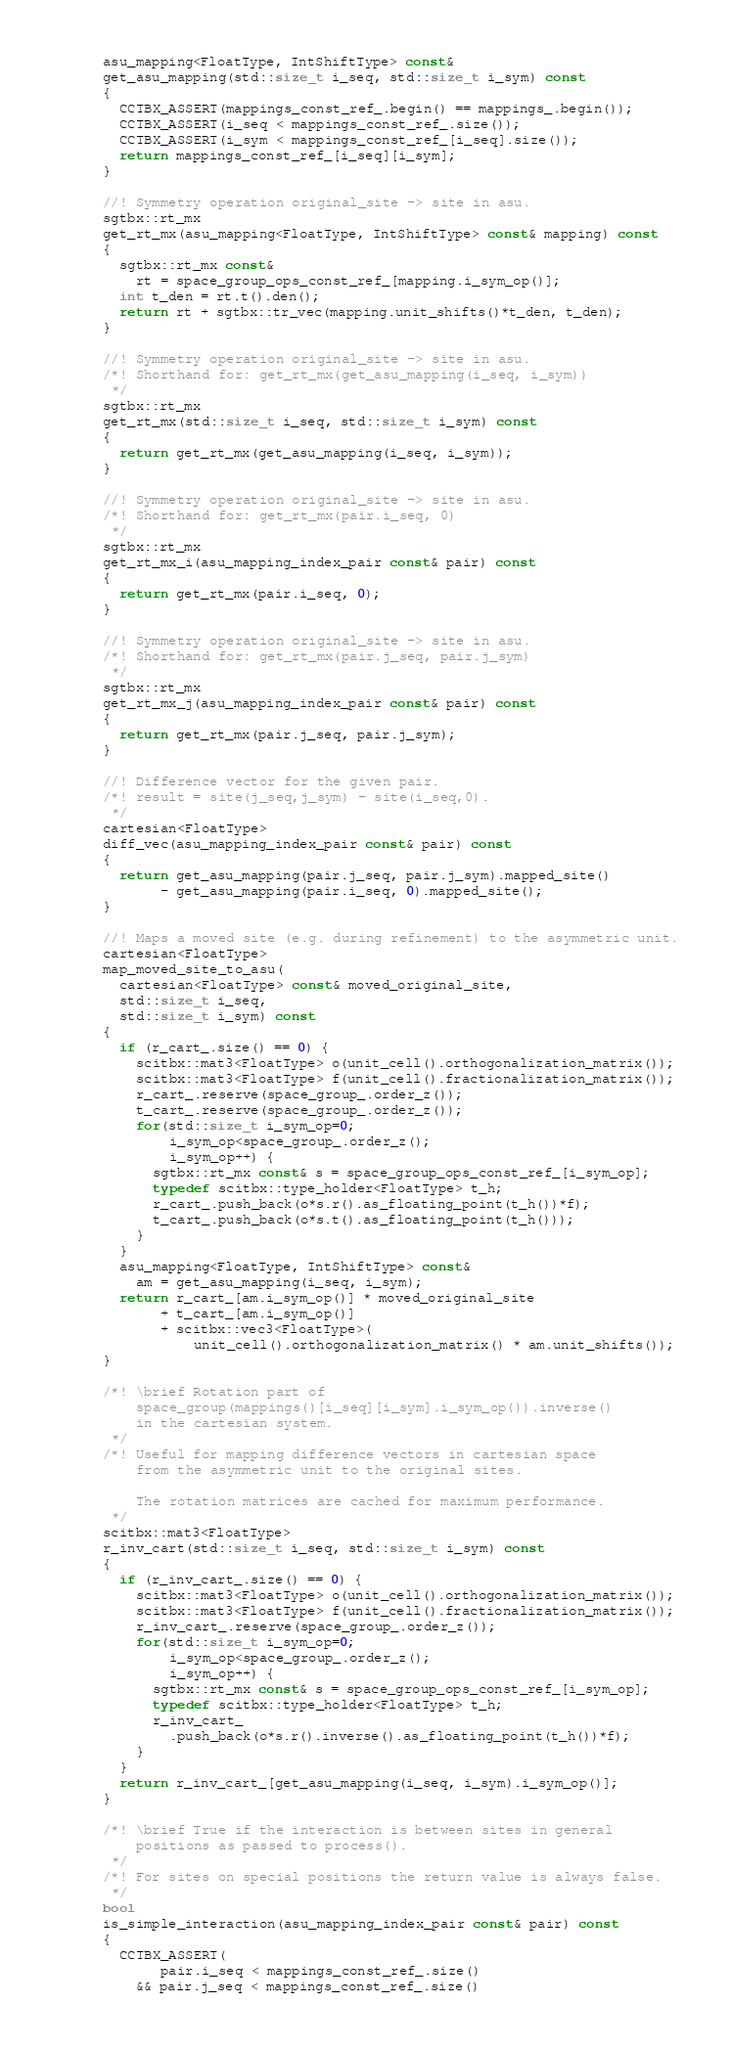Convert code to text. <code><loc_0><loc_0><loc_500><loc_500><_C_>      asu_mapping<FloatType, IntShiftType> const&
      get_asu_mapping(std::size_t i_seq, std::size_t i_sym) const
      {
        CCTBX_ASSERT(mappings_const_ref_.begin() == mappings_.begin());
        CCTBX_ASSERT(i_seq < mappings_const_ref_.size());
        CCTBX_ASSERT(i_sym < mappings_const_ref_[i_seq].size());
        return mappings_const_ref_[i_seq][i_sym];
      }

      //! Symmetry operation original_site -> site in asu.
      sgtbx::rt_mx
      get_rt_mx(asu_mapping<FloatType, IntShiftType> const& mapping) const
      {
        sgtbx::rt_mx const&
          rt = space_group_ops_const_ref_[mapping.i_sym_op()];
        int t_den = rt.t().den();
        return rt + sgtbx::tr_vec(mapping.unit_shifts()*t_den, t_den);
      }

      //! Symmetry operation original_site -> site in asu.
      /*! Shorthand for: get_rt_mx(get_asu_mapping(i_seq, i_sym))
       */
      sgtbx::rt_mx
      get_rt_mx(std::size_t i_seq, std::size_t i_sym) const
      {
        return get_rt_mx(get_asu_mapping(i_seq, i_sym));
      }

      //! Symmetry operation original_site -> site in asu.
      /*! Shorthand for: get_rt_mx(pair.i_seq, 0)
       */
      sgtbx::rt_mx
      get_rt_mx_i(asu_mapping_index_pair const& pair) const
      {
        return get_rt_mx(pair.i_seq, 0);
      }

      //! Symmetry operation original_site -> site in asu.
      /*! Shorthand for: get_rt_mx(pair.j_seq, pair.j_sym)
       */
      sgtbx::rt_mx
      get_rt_mx_j(asu_mapping_index_pair const& pair) const
      {
        return get_rt_mx(pair.j_seq, pair.j_sym);
      }

      //! Difference vector for the given pair.
      /*! result = site(j_seq,j_sym) - site(i_seq,0).
       */
      cartesian<FloatType>
      diff_vec(asu_mapping_index_pair const& pair) const
      {
        return get_asu_mapping(pair.j_seq, pair.j_sym).mapped_site()
             - get_asu_mapping(pair.i_seq, 0).mapped_site();
      }

      //! Maps a moved site (e.g. during refinement) to the asymmetric unit.
      cartesian<FloatType>
      map_moved_site_to_asu(
        cartesian<FloatType> const& moved_original_site,
        std::size_t i_seq,
        std::size_t i_sym) const
      {
        if (r_cart_.size() == 0) {
          scitbx::mat3<FloatType> o(unit_cell().orthogonalization_matrix());
          scitbx::mat3<FloatType> f(unit_cell().fractionalization_matrix());
          r_cart_.reserve(space_group_.order_z());
          t_cart_.reserve(space_group_.order_z());
          for(std::size_t i_sym_op=0;
              i_sym_op<space_group_.order_z();
              i_sym_op++) {
            sgtbx::rt_mx const& s = space_group_ops_const_ref_[i_sym_op];
            typedef scitbx::type_holder<FloatType> t_h;
            r_cart_.push_back(o*s.r().as_floating_point(t_h())*f);
            t_cart_.push_back(o*s.t().as_floating_point(t_h()));
          }
        }
        asu_mapping<FloatType, IntShiftType> const&
          am = get_asu_mapping(i_seq, i_sym);
        return r_cart_[am.i_sym_op()] * moved_original_site
             + t_cart_[am.i_sym_op()]
             + scitbx::vec3<FloatType>(
                 unit_cell().orthogonalization_matrix() * am.unit_shifts());
      }

      /*! \brief Rotation part of
          space_group(mappings()[i_seq][i_sym].i_sym_op()).inverse()
          in the cartesian system.
       */
      /*! Useful for mapping difference vectors in cartesian space
          from the asymmetric unit to the original sites.

          The rotation matrices are cached for maximum performance.
       */
      scitbx::mat3<FloatType>
      r_inv_cart(std::size_t i_seq, std::size_t i_sym) const
      {
        if (r_inv_cart_.size() == 0) {
          scitbx::mat3<FloatType> o(unit_cell().orthogonalization_matrix());
          scitbx::mat3<FloatType> f(unit_cell().fractionalization_matrix());
          r_inv_cart_.reserve(space_group_.order_z());
          for(std::size_t i_sym_op=0;
              i_sym_op<space_group_.order_z();
              i_sym_op++) {
            sgtbx::rt_mx const& s = space_group_ops_const_ref_[i_sym_op];
            typedef scitbx::type_holder<FloatType> t_h;
            r_inv_cart_
              .push_back(o*s.r().inverse().as_floating_point(t_h())*f);
          }
        }
        return r_inv_cart_[get_asu_mapping(i_seq, i_sym).i_sym_op()];
      }

      /*! \brief True if the interaction is between sites in general
          positions as passed to process().
       */
      /*! For sites on special positions the return value is always false.
       */
      bool
      is_simple_interaction(asu_mapping_index_pair const& pair) const
      {
        CCTBX_ASSERT(
             pair.i_seq < mappings_const_ref_.size()
          && pair.j_seq < mappings_const_ref_.size()</code> 